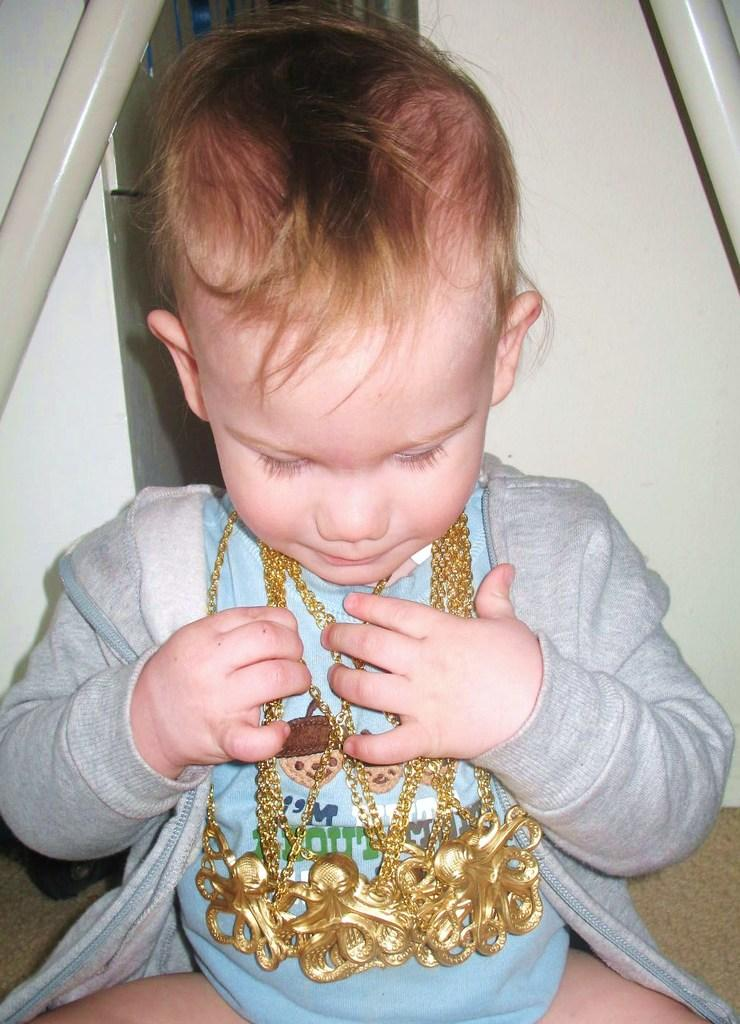What is the main subject of the image? There is a baby in the image. What is the baby doing in the image? The baby is sitting on the ground. What accessories is the baby wearing in the image? The baby is wearing gold necklaces and an ash-colored jacket. What type of joke is the baby telling in the image? There is no indication in the image that the baby is telling a joke, as babies typically do not tell jokes. 